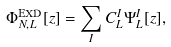Convert formula to latex. <formula><loc_0><loc_0><loc_500><loc_500>\Phi ^ { \text {EXD} } _ { N , L } [ z ] = \sum _ { I } C ^ { I } _ { L } \Psi _ { L } ^ { I } [ z ] ,</formula> 